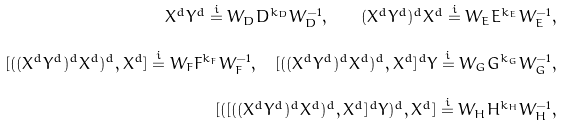<formula> <loc_0><loc_0><loc_500><loc_500>X ^ { d } Y ^ { d } \overset { i } = W _ { D } D ^ { k _ { D } } W _ { D } ^ { - 1 } , \quad ( X ^ { d } Y ^ { d } ) ^ { d } X ^ { d } \overset { i } = W _ { E } E ^ { k _ { E } } W _ { E } ^ { - 1 } , \\ [ ( ( X ^ { d } Y ^ { d } ) ^ { d } X ^ { d } ) ^ { d } , X ^ { d } ] \overset { i } = W _ { F } F ^ { k _ { F } } W _ { F } ^ { - 1 } , \quad [ ( ( X ^ { d } Y ^ { d } ) ^ { d } X ^ { d } ) ^ { d } , X ^ { d } ] ^ { d } Y \overset { i } = W _ { G } G ^ { k _ { G } } W _ { G } ^ { - 1 } , \\ [ ( [ ( ( X ^ { d } Y ^ { d } ) ^ { d } X ^ { d } ) ^ { d } , X ^ { d } ] ^ { d } Y ) ^ { d } , X ^ { d } ] \overset { i } = W _ { H } H ^ { k _ { H } } W _ { H } ^ { - 1 } ,</formula> 